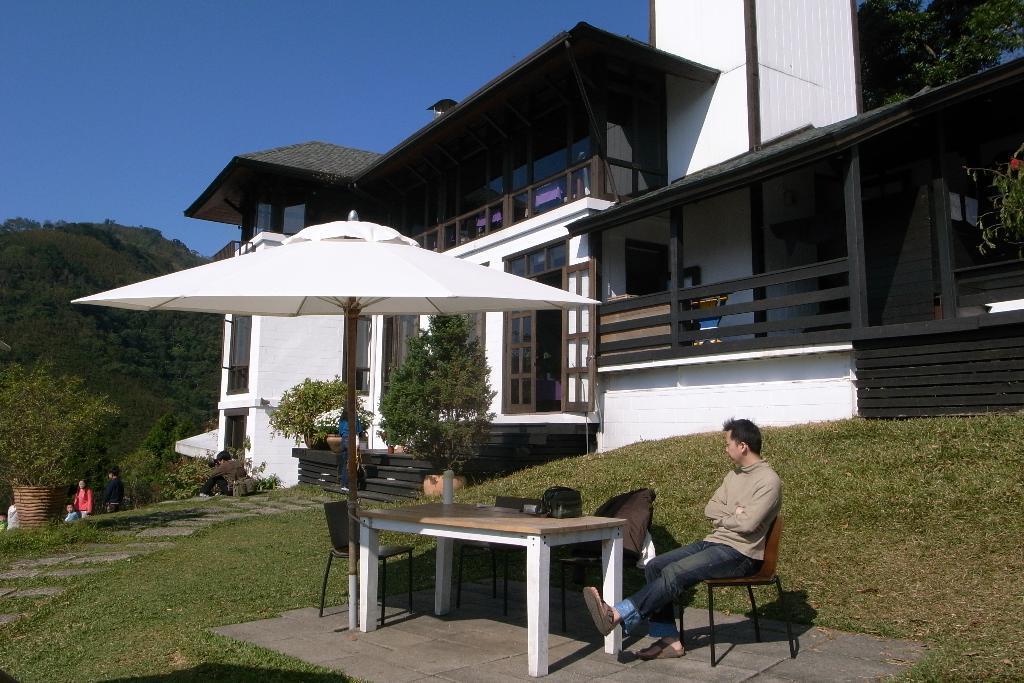In one or two sentences, can you explain what this image depicts? This picture describes about group of people, in the right side of the given image we can see a man, he is seated on the chair, in front of him we can find a table and an umbrella, in the background we can find a house and trees. 